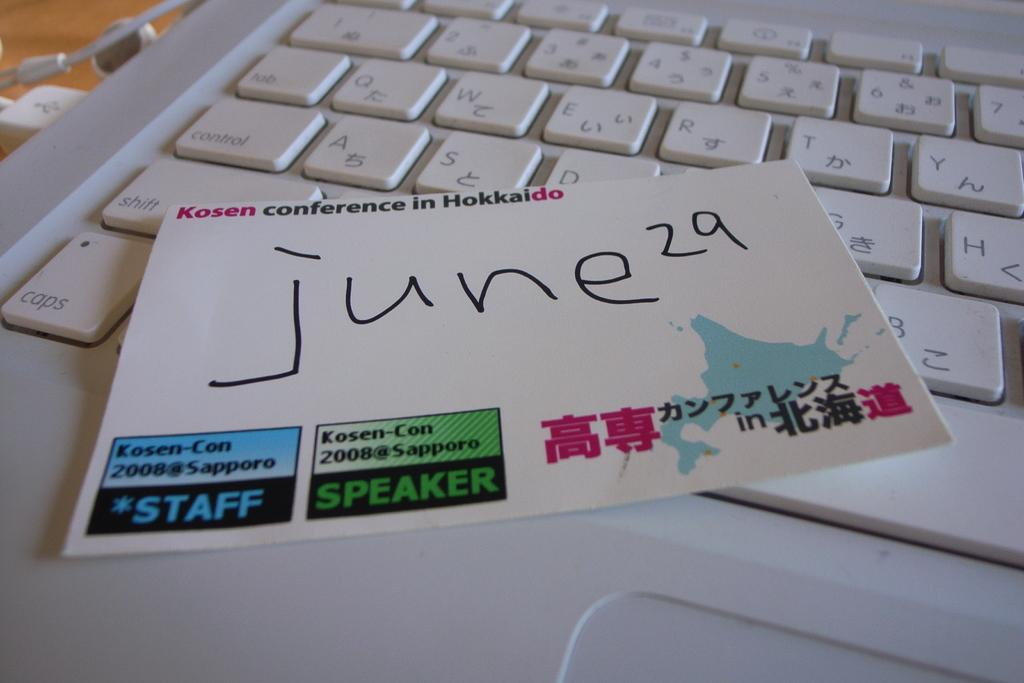<image>
Write a terse but informative summary of the picture. A note card from the Kosen conference with the date of June 29th on it. 